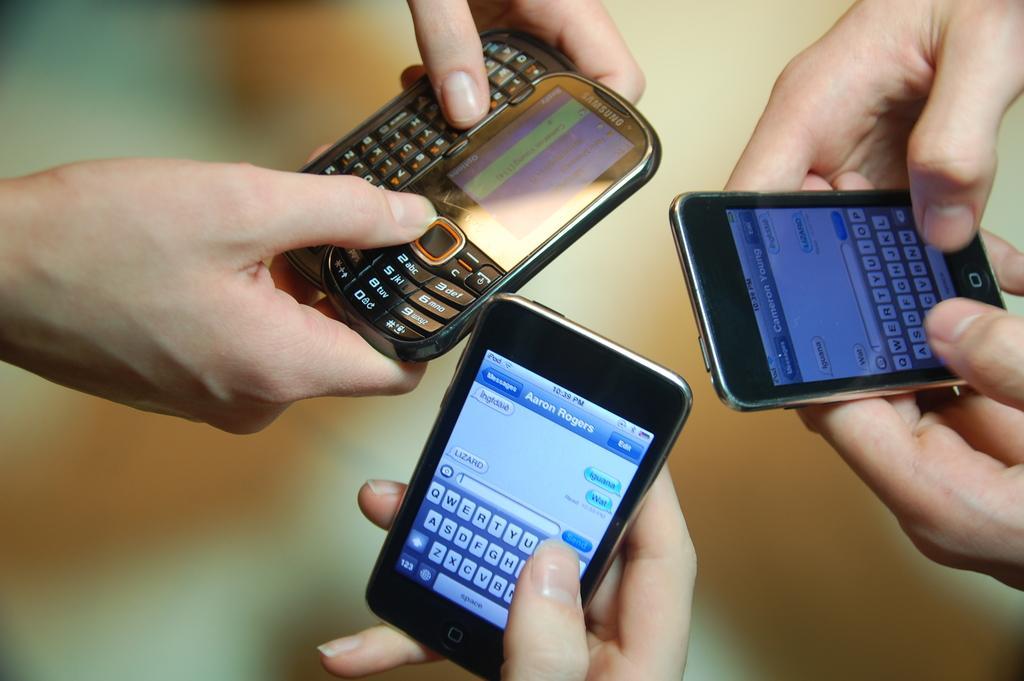Describe this image in one or two sentences. In this image we can see the hands of the persons. The persons are holding mobiles. The background of the image is blurred. 